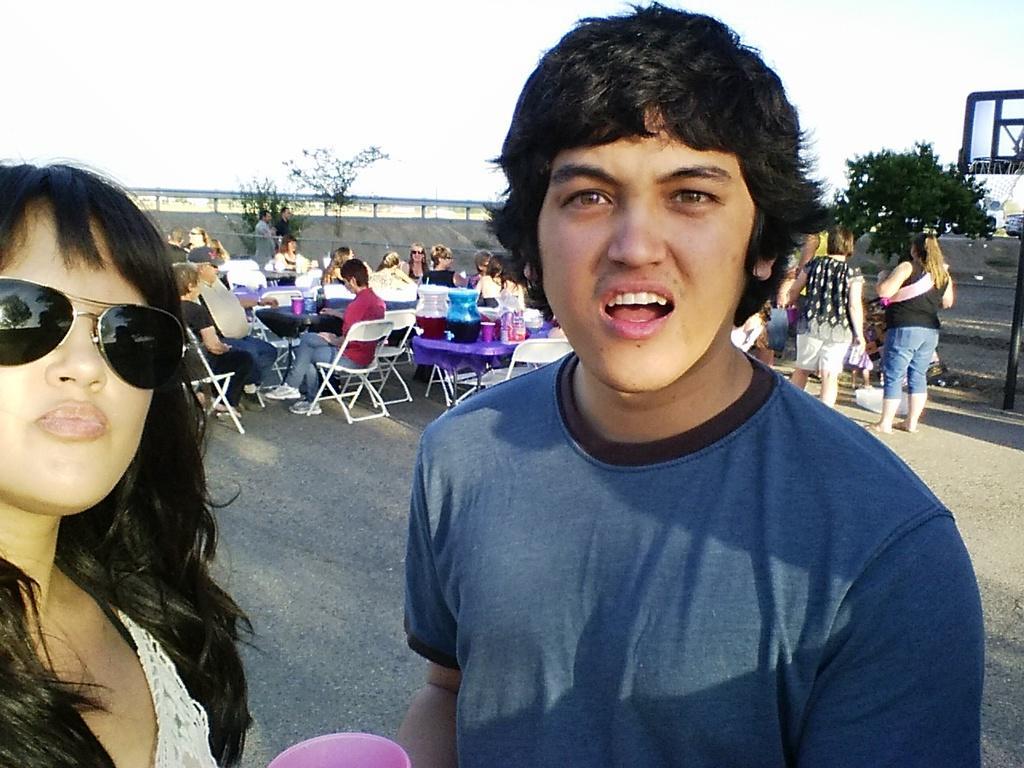How would you summarize this image in a sentence or two? In this image we can see persons and an object. In the background of the image there are persons, chairs, plants, trees and other objects. At the top of the image there is the sky. 